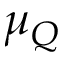<formula> <loc_0><loc_0><loc_500><loc_500>\mu _ { Q }</formula> 